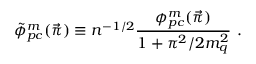<formula> <loc_0><loc_0><loc_500><loc_500>\tilde { \phi } _ { p c } ^ { m } ( \vec { \pi } ) \equiv n ^ { - 1 / 2 } { \frac { \phi _ { p c } ^ { m } ( \vec { \pi } ) } { 1 + \pi ^ { 2 } / 2 m _ { q } ^ { 2 } } } .</formula> 